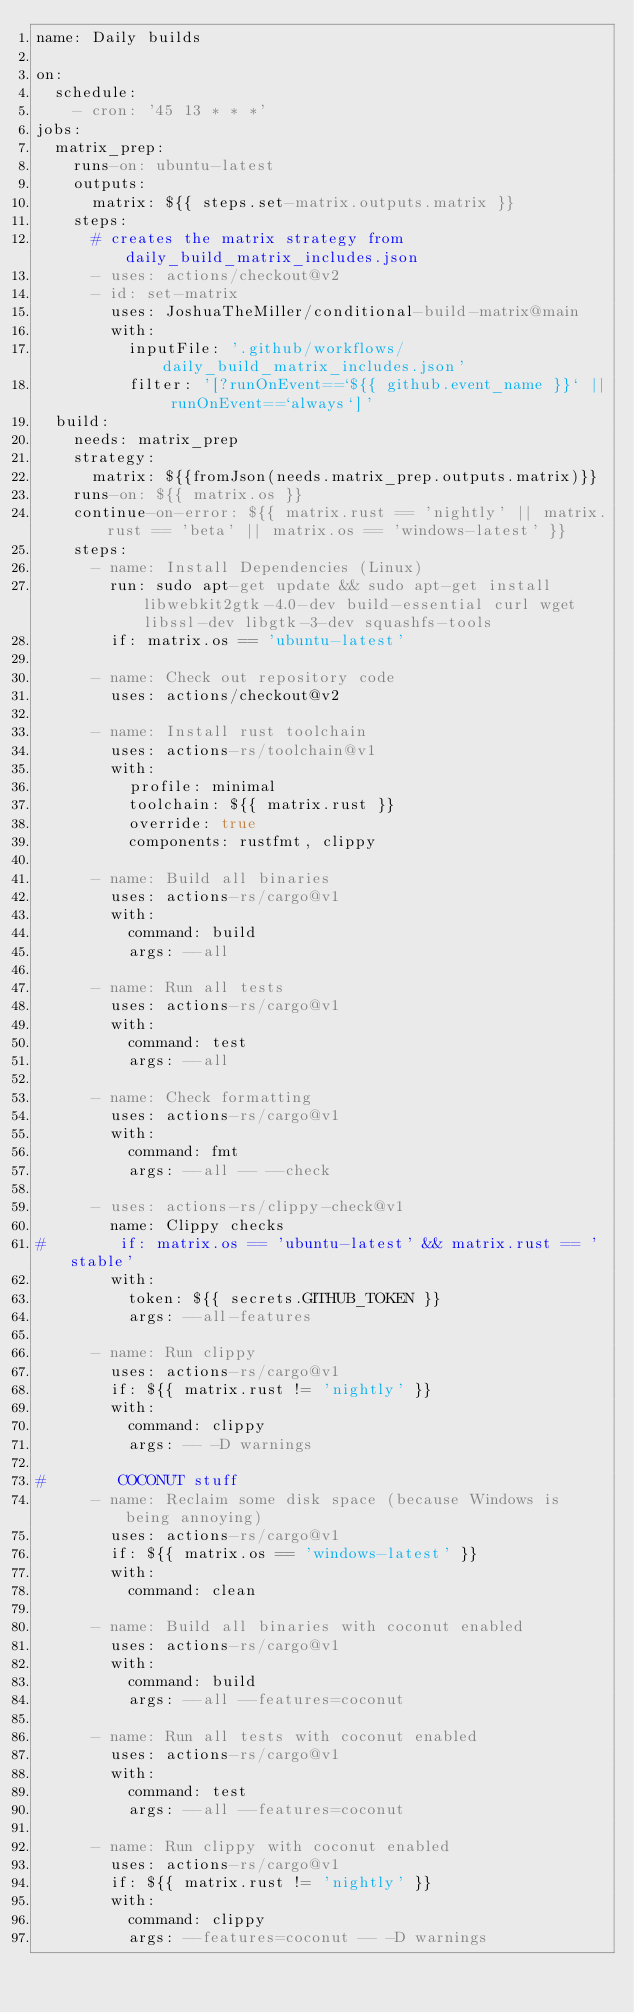<code> <loc_0><loc_0><loc_500><loc_500><_YAML_>name: Daily builds

on:
  schedule:
    - cron: '45 13 * * *'
jobs:
  matrix_prep:
    runs-on: ubuntu-latest
    outputs:
      matrix: ${{ steps.set-matrix.outputs.matrix }}
    steps:
      # creates the matrix strategy from daily_build_matrix_includes.json
      - uses: actions/checkout@v2
      - id: set-matrix
        uses: JoshuaTheMiller/conditional-build-matrix@main
        with:
          inputFile: '.github/workflows/daily_build_matrix_includes.json'
          filter: '[?runOnEvent==`${{ github.event_name }}` || runOnEvent==`always`]'
  build:
    needs: matrix_prep
    strategy:
      matrix: ${{fromJson(needs.matrix_prep.outputs.matrix)}}
    runs-on: ${{ matrix.os }}
    continue-on-error: ${{ matrix.rust == 'nightly' || matrix.rust == 'beta' || matrix.os == 'windows-latest' }}
    steps:
      - name: Install Dependencies (Linux)
        run: sudo apt-get update && sudo apt-get install libwebkit2gtk-4.0-dev build-essential curl wget libssl-dev libgtk-3-dev squashfs-tools
        if: matrix.os == 'ubuntu-latest'

      - name: Check out repository code
        uses: actions/checkout@v2

      - name: Install rust toolchain
        uses: actions-rs/toolchain@v1
        with:
          profile: minimal
          toolchain: ${{ matrix.rust }}
          override: true
          components: rustfmt, clippy

      - name: Build all binaries
        uses: actions-rs/cargo@v1
        with:
          command: build
          args: --all

      - name: Run all tests
        uses: actions-rs/cargo@v1
        with:
          command: test
          args: --all

      - name: Check formatting
        uses: actions-rs/cargo@v1
        with:
          command: fmt
          args: --all -- --check

      - uses: actions-rs/clippy-check@v1
        name: Clippy checks
#        if: matrix.os == 'ubuntu-latest' && matrix.rust == 'stable'
        with:
          token: ${{ secrets.GITHUB_TOKEN }}
          args: --all-features

      - name: Run clippy
        uses: actions-rs/cargo@v1
        if: ${{ matrix.rust != 'nightly' }}
        with:
          command: clippy
          args: -- -D warnings

#        COCONUT stuff
      - name: Reclaim some disk space (because Windows is being annoying)
        uses: actions-rs/cargo@v1
        if: ${{ matrix.os == 'windows-latest' }}
        with:
          command: clean

      - name: Build all binaries with coconut enabled
        uses: actions-rs/cargo@v1
        with:
          command: build
          args: --all --features=coconut

      - name: Run all tests with coconut enabled
        uses: actions-rs/cargo@v1
        with:
          command: test
          args: --all --features=coconut

      - name: Run clippy with coconut enabled
        uses: actions-rs/cargo@v1
        if: ${{ matrix.rust != 'nightly' }}
        with:
          command: clippy
          args: --features=coconut -- -D warnings
</code> 